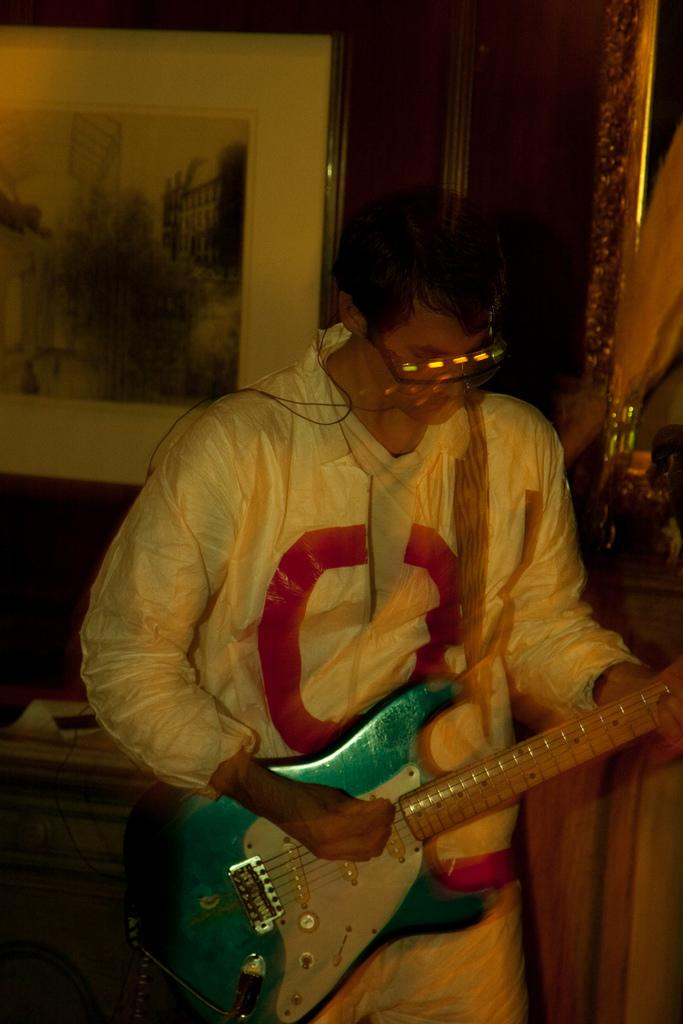What is the man in the image doing? The man is playing a guitar in the image. What accessory is the man wearing? The man is wearing spectacles. Can you describe the background of the image? There is a photo frame in the background of the image, and it is attached to the wall. What type of riddle is the man solving in the image? There is no riddle present in the image; the man is playing a guitar. Can you see any bones in the image? There are no bones visible in the image. 